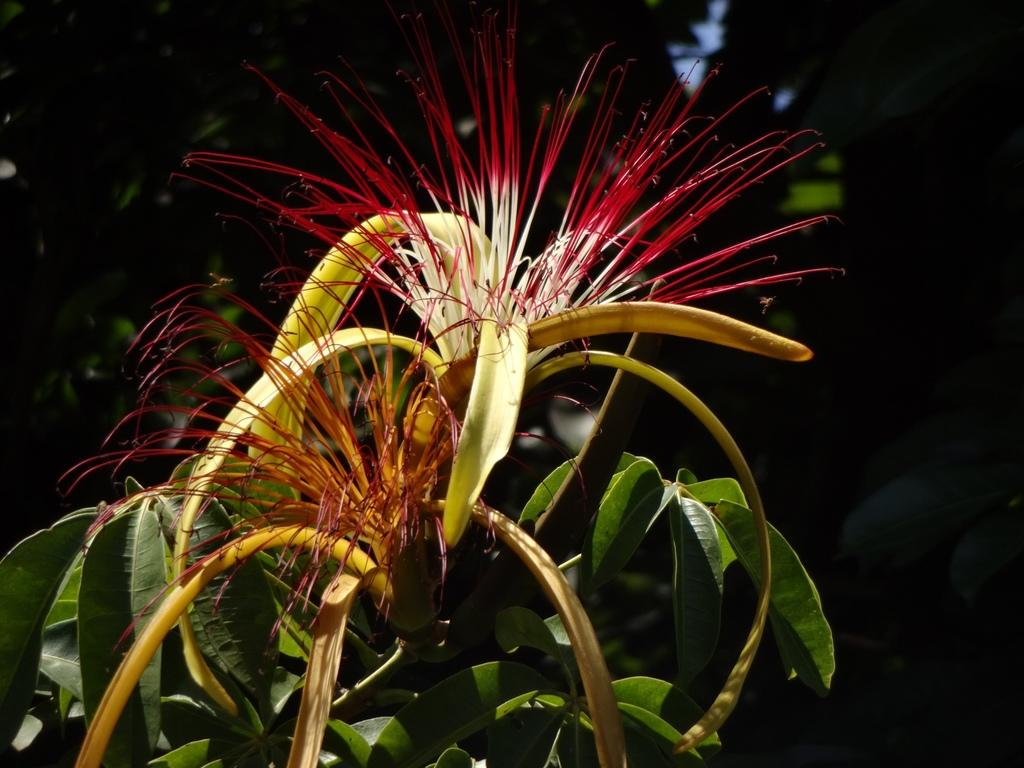What type of plants are visible in the image? There are plants with flowers in the image. How would you describe the background of the image? The background of the image is dark. How many distribution centers are visible in the image? There are no distribution centers present in the image; it features plants with flowers and a dark background. What type of cracker is being used to water the plants in the image? There is no cracker present in the image, and plants do not require crackers for watering. 